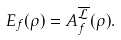<formula> <loc_0><loc_0><loc_500><loc_500>E _ { f } ( \rho ) = A _ { f } ^ { \overline { \mathcal { L } } } ( \rho ) .</formula> 